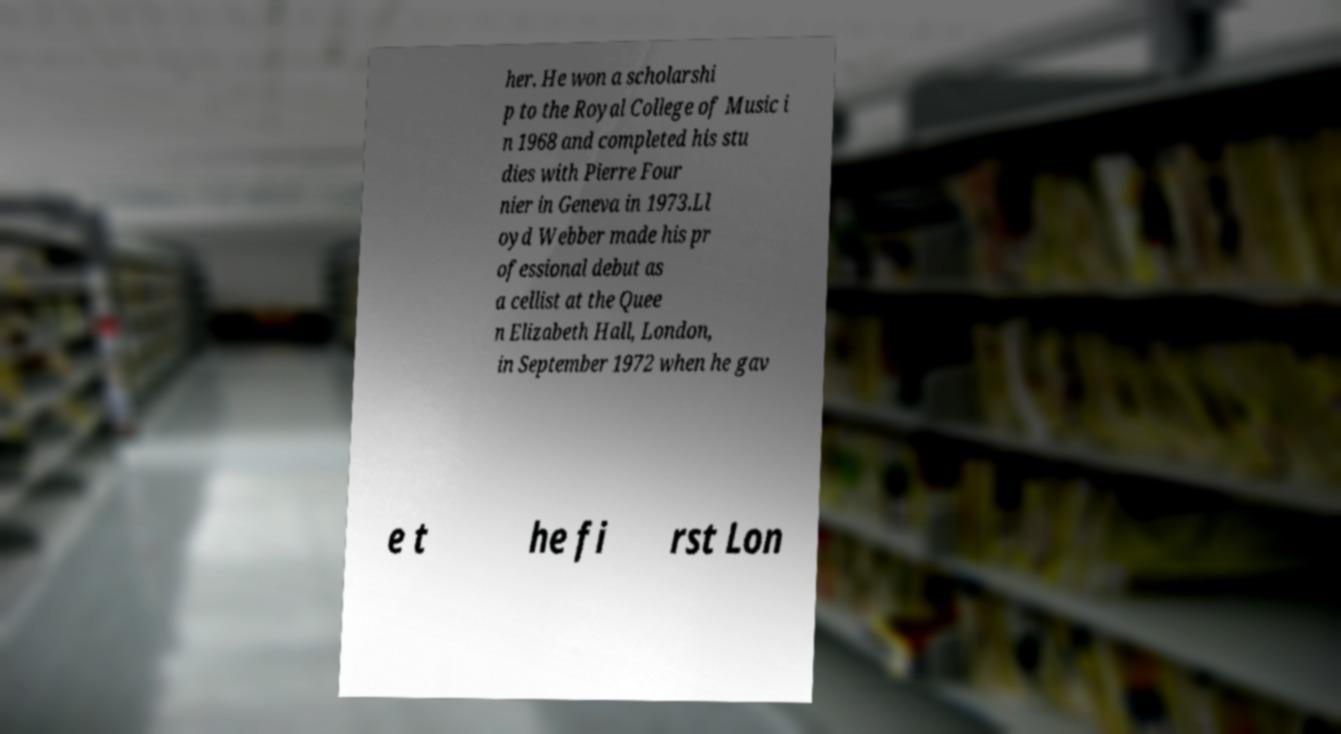Could you extract and type out the text from this image? her. He won a scholarshi p to the Royal College of Music i n 1968 and completed his stu dies with Pierre Four nier in Geneva in 1973.Ll oyd Webber made his pr ofessional debut as a cellist at the Quee n Elizabeth Hall, London, in September 1972 when he gav e t he fi rst Lon 